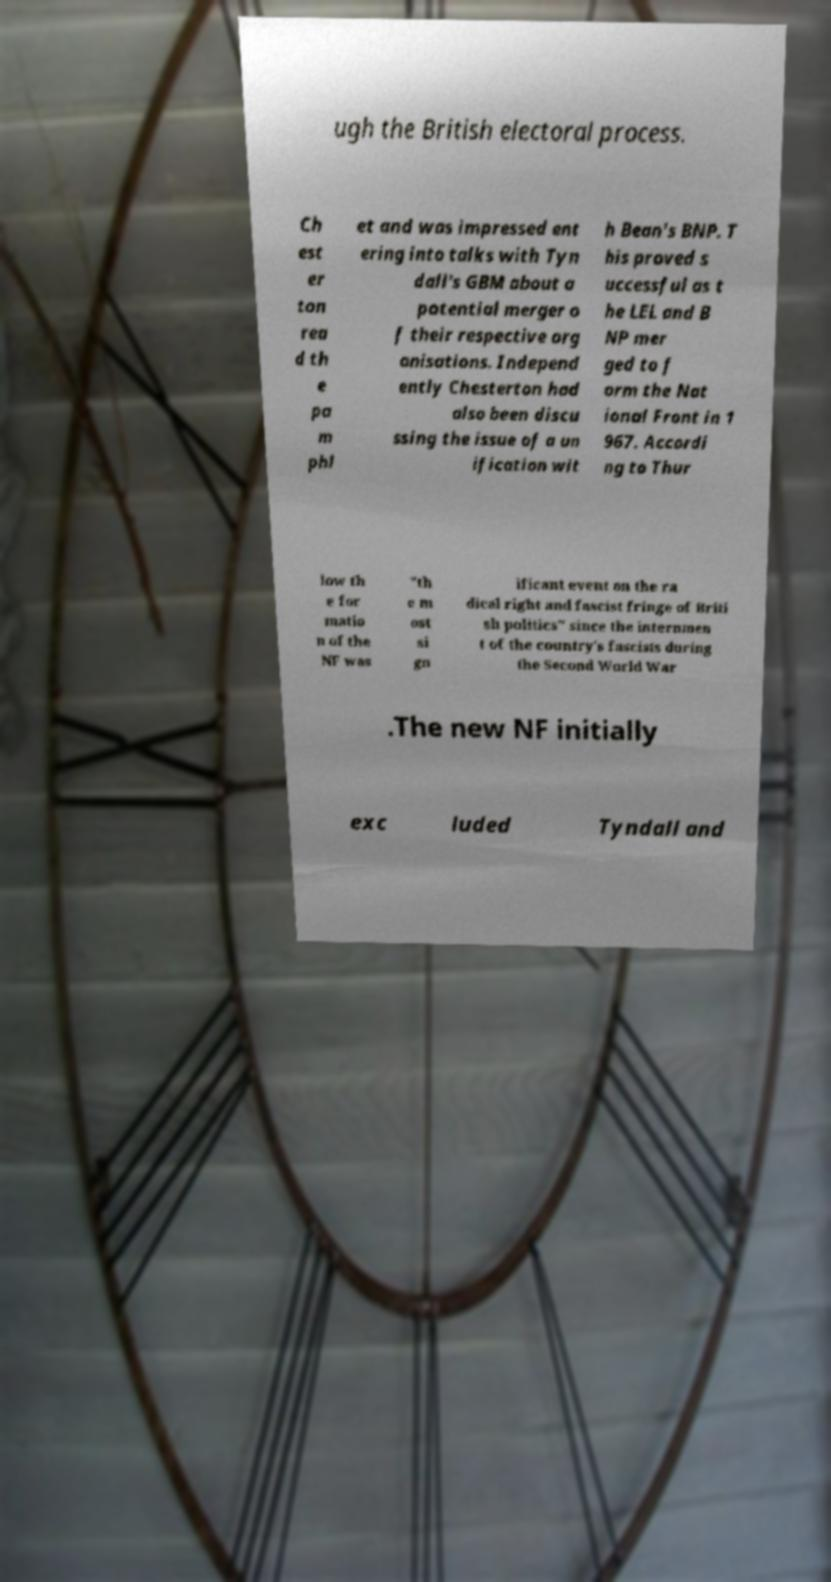What messages or text are displayed in this image? I need them in a readable, typed format. ugh the British electoral process. Ch est er ton rea d th e pa m phl et and was impressed ent ering into talks with Tyn dall's GBM about a potential merger o f their respective org anisations. Independ ently Chesterton had also been discu ssing the issue of a un ification wit h Bean's BNP. T his proved s uccessful as t he LEL and B NP mer ged to f orm the Nat ional Front in 1 967. Accordi ng to Thur low th e for matio n of the NF was "th e m ost si gn ificant event on the ra dical right and fascist fringe of Briti sh politics" since the internmen t of the country's fascists during the Second World War .The new NF initially exc luded Tyndall and 